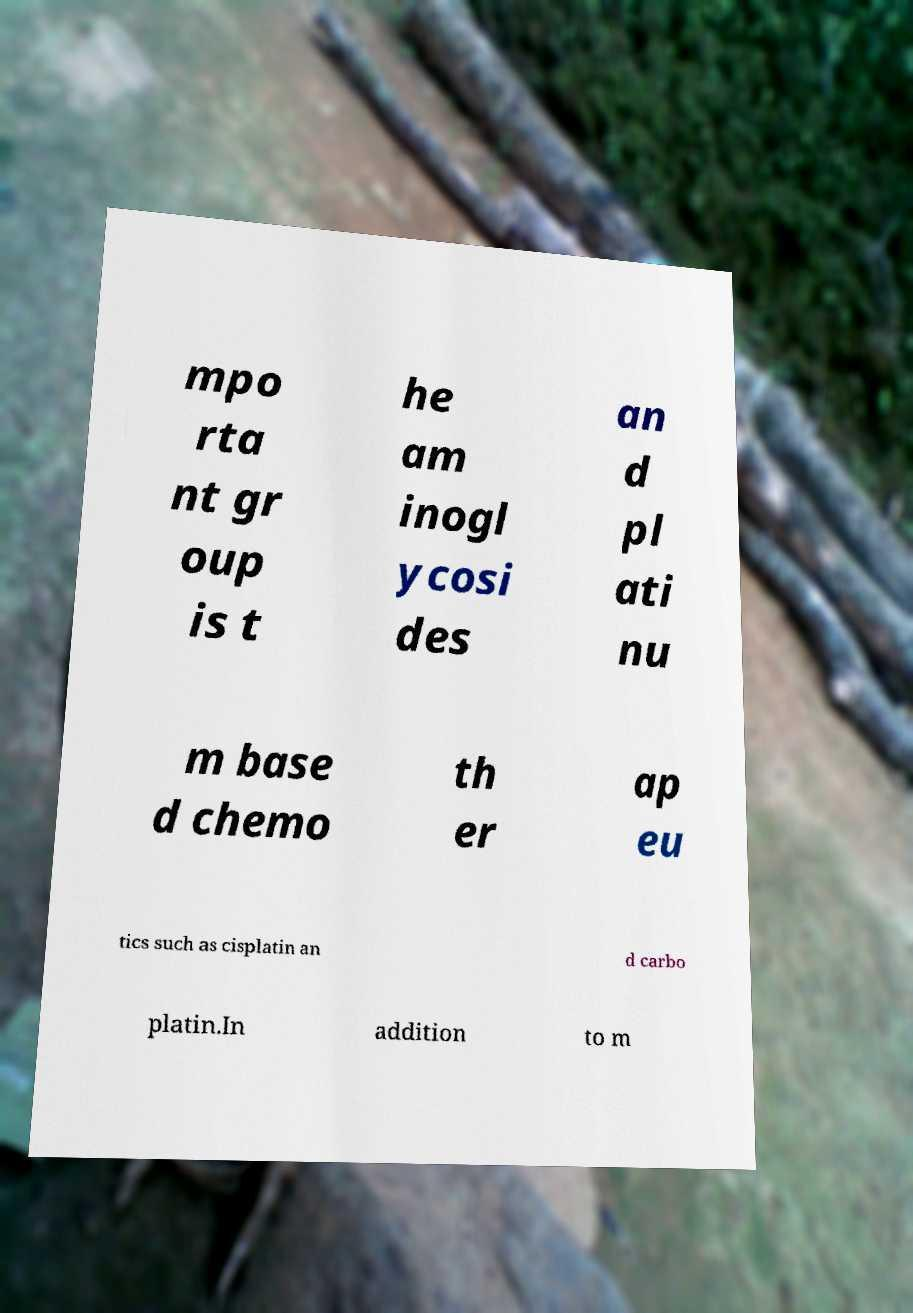Could you assist in decoding the text presented in this image and type it out clearly? mpo rta nt gr oup is t he am inogl ycosi des an d pl ati nu m base d chemo th er ap eu tics such as cisplatin an d carbo platin.In addition to m 